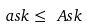Convert formula to latex. <formula><loc_0><loc_0><loc_500><loc_500>\ a s { k } \leq \ A s { k }</formula> 